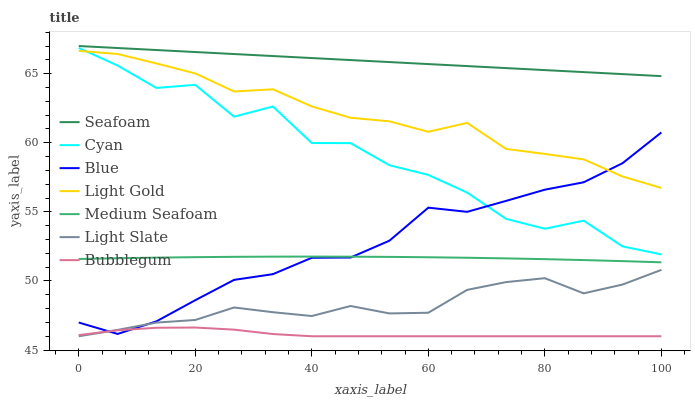Does Bubblegum have the minimum area under the curve?
Answer yes or no. Yes. Does Seafoam have the maximum area under the curve?
Answer yes or no. Yes. Does Light Slate have the minimum area under the curve?
Answer yes or no. No. Does Light Slate have the maximum area under the curve?
Answer yes or no. No. Is Seafoam the smoothest?
Answer yes or no. Yes. Is Cyan the roughest?
Answer yes or no. Yes. Is Light Slate the smoothest?
Answer yes or no. No. Is Light Slate the roughest?
Answer yes or no. No. Does Light Slate have the lowest value?
Answer yes or no. Yes. Does Seafoam have the lowest value?
Answer yes or no. No. Does Seafoam have the highest value?
Answer yes or no. Yes. Does Light Slate have the highest value?
Answer yes or no. No. Is Bubblegum less than Light Gold?
Answer yes or no. Yes. Is Seafoam greater than Medium Seafoam?
Answer yes or no. Yes. Does Blue intersect Cyan?
Answer yes or no. Yes. Is Blue less than Cyan?
Answer yes or no. No. Is Blue greater than Cyan?
Answer yes or no. No. Does Bubblegum intersect Light Gold?
Answer yes or no. No. 